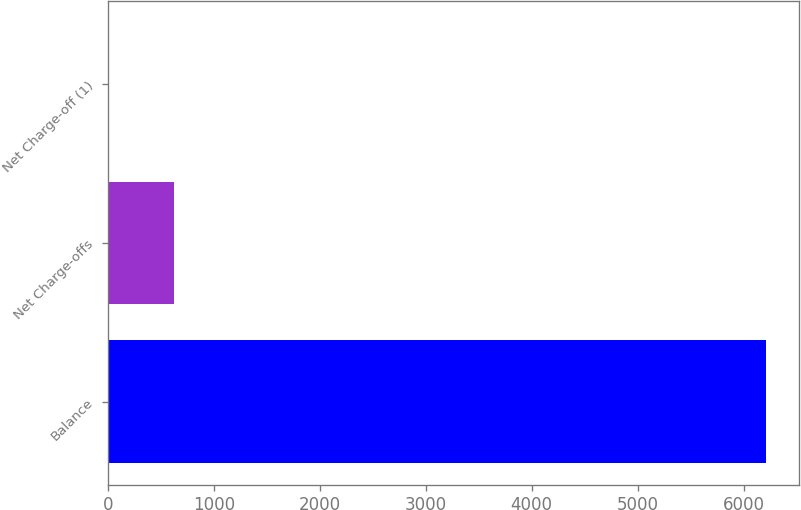Convert chart. <chart><loc_0><loc_0><loc_500><loc_500><bar_chart><fcel>Balance<fcel>Net Charge-offs<fcel>Net Charge-off (1)<nl><fcel>6213<fcel>622.58<fcel>1.42<nl></chart> 